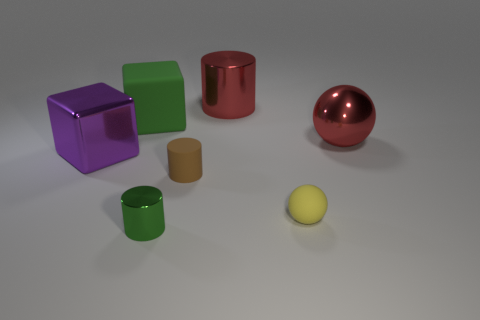Is the material of the small thing to the left of the brown object the same as the yellow object?
Provide a succinct answer. No. What number of other yellow balls are the same size as the rubber sphere?
Provide a succinct answer. 0. Are there more large green blocks that are in front of the big rubber cube than brown rubber cylinders that are to the left of the tiny brown object?
Your response must be concise. No. Are there any large gray matte things that have the same shape as the big purple metallic thing?
Keep it short and to the point. No. There is a green thing in front of the big block right of the large purple metallic object; how big is it?
Your response must be concise. Small. What shape is the green object that is in front of the large shiny object on the left side of the green thing in front of the small brown cylinder?
Ensure brevity in your answer.  Cylinder. There is a green thing that is made of the same material as the purple cube; what size is it?
Make the answer very short. Small. Is the number of purple rubber objects greater than the number of green rubber objects?
Provide a succinct answer. No. There is a yellow thing that is the same size as the brown matte object; what is it made of?
Give a very brief answer. Rubber. Does the cylinder on the left side of the brown object have the same size as the small brown rubber object?
Offer a very short reply. Yes. 